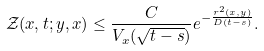<formula> <loc_0><loc_0><loc_500><loc_500>\mathcal { Z } ( x , t ; y , x ) \leq \frac { C } { V _ { x } ( \sqrt { t - s } ) } e ^ { - \frac { r ^ { 2 } ( x , y ) } { D ( t - s ) } } .</formula> 